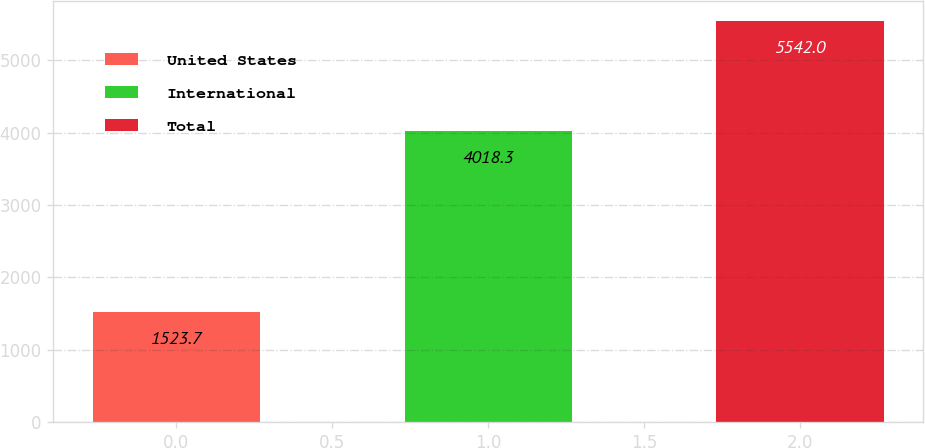Convert chart to OTSL. <chart><loc_0><loc_0><loc_500><loc_500><bar_chart><fcel>United States<fcel>International<fcel>Total<nl><fcel>1523.7<fcel>4018.3<fcel>5542<nl></chart> 